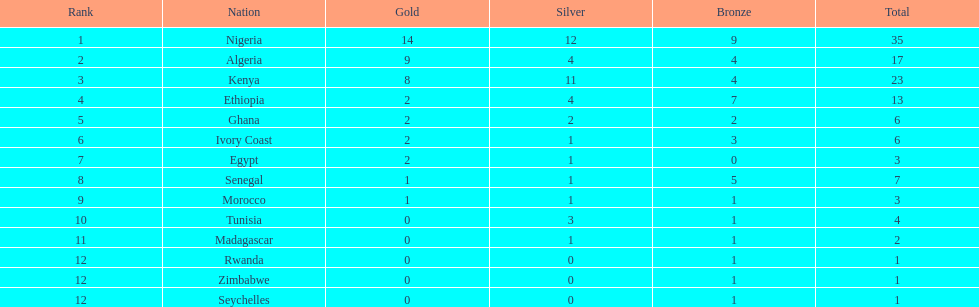What is the name of the first nation on this chart? Nigeria. 